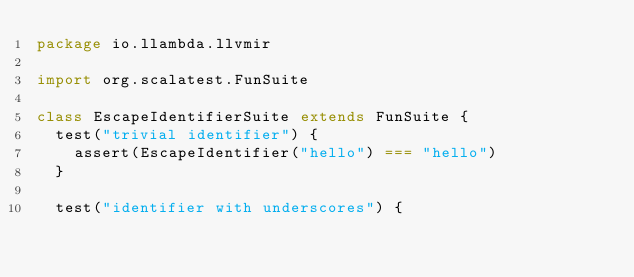<code> <loc_0><loc_0><loc_500><loc_500><_Scala_>package io.llambda.llvmir

import org.scalatest.FunSuite

class EscapeIdentifierSuite extends FunSuite {
  test("trivial identifier") {
    assert(EscapeIdentifier("hello") === "hello")
  }
  
  test("identifier with underscores") {</code> 